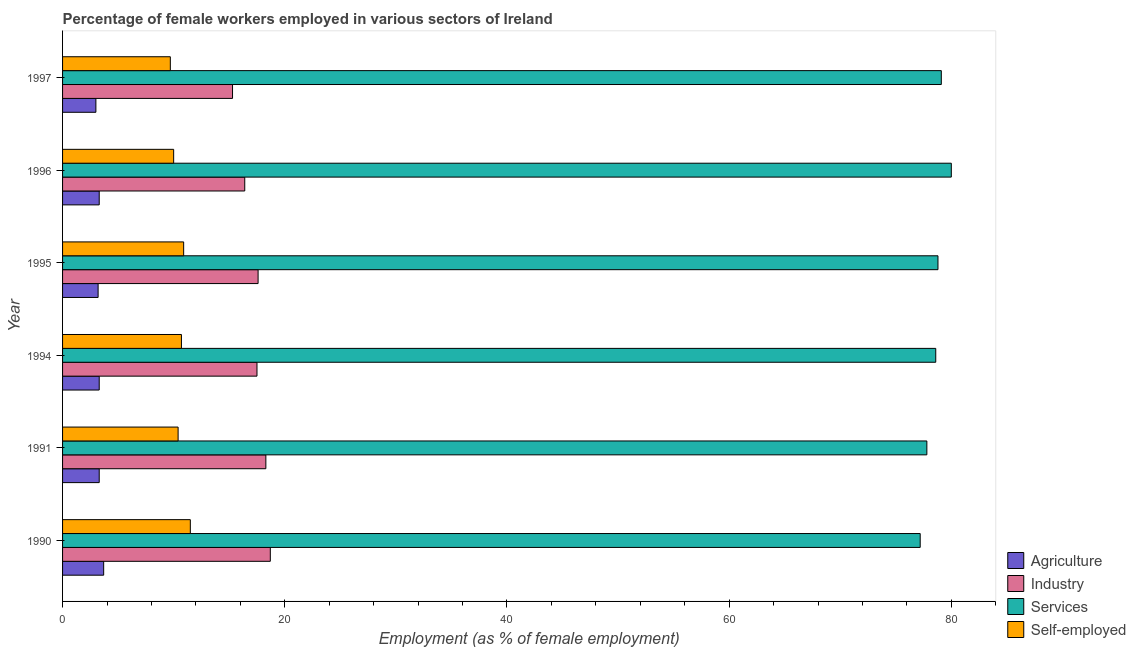Are the number of bars per tick equal to the number of legend labels?
Offer a terse response. Yes. Are the number of bars on each tick of the Y-axis equal?
Offer a very short reply. Yes. How many bars are there on the 5th tick from the top?
Offer a terse response. 4. How many bars are there on the 4th tick from the bottom?
Give a very brief answer. 4. What is the label of the 2nd group of bars from the top?
Your response must be concise. 1996. What is the percentage of female workers in services in 1995?
Give a very brief answer. 78.8. Across all years, what is the maximum percentage of female workers in industry?
Offer a very short reply. 18.7. In which year was the percentage of female workers in services maximum?
Give a very brief answer. 1996. In which year was the percentage of female workers in services minimum?
Offer a very short reply. 1990. What is the total percentage of female workers in industry in the graph?
Provide a short and direct response. 103.8. What is the difference between the percentage of self employed female workers in 1990 and that in 1991?
Your response must be concise. 1.1. What is the difference between the percentage of female workers in services in 1996 and the percentage of self employed female workers in 1994?
Offer a terse response. 69.3. What is the average percentage of self employed female workers per year?
Offer a very short reply. 10.53. In the year 1991, what is the difference between the percentage of self employed female workers and percentage of female workers in industry?
Make the answer very short. -7.9. In how many years, is the percentage of female workers in industry greater than 32 %?
Ensure brevity in your answer.  0. What is the ratio of the percentage of female workers in industry in 1991 to that in 1994?
Your response must be concise. 1.05. Is the percentage of female workers in agriculture in 1990 less than that in 1997?
Your answer should be compact. No. Is the difference between the percentage of female workers in industry in 1994 and 1997 greater than the difference between the percentage of self employed female workers in 1994 and 1997?
Provide a succinct answer. Yes. What is the difference between the highest and the second highest percentage of female workers in agriculture?
Offer a terse response. 0.4. In how many years, is the percentage of female workers in services greater than the average percentage of female workers in services taken over all years?
Give a very brief answer. 4. Is the sum of the percentage of self employed female workers in 1996 and 1997 greater than the maximum percentage of female workers in industry across all years?
Offer a very short reply. Yes. What does the 1st bar from the top in 1997 represents?
Give a very brief answer. Self-employed. What does the 4th bar from the bottom in 1994 represents?
Offer a terse response. Self-employed. Is it the case that in every year, the sum of the percentage of female workers in agriculture and percentage of female workers in industry is greater than the percentage of female workers in services?
Ensure brevity in your answer.  No. How many bars are there?
Ensure brevity in your answer.  24. Does the graph contain any zero values?
Provide a succinct answer. No. Does the graph contain grids?
Keep it short and to the point. No. Where does the legend appear in the graph?
Make the answer very short. Bottom right. What is the title of the graph?
Ensure brevity in your answer.  Percentage of female workers employed in various sectors of Ireland. What is the label or title of the X-axis?
Offer a very short reply. Employment (as % of female employment). What is the label or title of the Y-axis?
Your answer should be compact. Year. What is the Employment (as % of female employment) in Agriculture in 1990?
Give a very brief answer. 3.7. What is the Employment (as % of female employment) of Industry in 1990?
Provide a succinct answer. 18.7. What is the Employment (as % of female employment) of Services in 1990?
Provide a short and direct response. 77.2. What is the Employment (as % of female employment) in Self-employed in 1990?
Make the answer very short. 11.5. What is the Employment (as % of female employment) in Agriculture in 1991?
Offer a terse response. 3.3. What is the Employment (as % of female employment) of Industry in 1991?
Provide a succinct answer. 18.3. What is the Employment (as % of female employment) of Services in 1991?
Your answer should be very brief. 77.8. What is the Employment (as % of female employment) in Self-employed in 1991?
Your answer should be very brief. 10.4. What is the Employment (as % of female employment) in Agriculture in 1994?
Your response must be concise. 3.3. What is the Employment (as % of female employment) in Services in 1994?
Make the answer very short. 78.6. What is the Employment (as % of female employment) in Self-employed in 1994?
Give a very brief answer. 10.7. What is the Employment (as % of female employment) of Agriculture in 1995?
Provide a succinct answer. 3.2. What is the Employment (as % of female employment) in Industry in 1995?
Provide a succinct answer. 17.6. What is the Employment (as % of female employment) in Services in 1995?
Give a very brief answer. 78.8. What is the Employment (as % of female employment) in Self-employed in 1995?
Your response must be concise. 10.9. What is the Employment (as % of female employment) of Agriculture in 1996?
Make the answer very short. 3.3. What is the Employment (as % of female employment) of Industry in 1996?
Provide a short and direct response. 16.4. What is the Employment (as % of female employment) of Self-employed in 1996?
Provide a succinct answer. 10. What is the Employment (as % of female employment) of Agriculture in 1997?
Your answer should be compact. 3. What is the Employment (as % of female employment) in Industry in 1997?
Offer a very short reply. 15.3. What is the Employment (as % of female employment) of Services in 1997?
Provide a succinct answer. 79.1. What is the Employment (as % of female employment) of Self-employed in 1997?
Make the answer very short. 9.7. Across all years, what is the maximum Employment (as % of female employment) of Agriculture?
Ensure brevity in your answer.  3.7. Across all years, what is the maximum Employment (as % of female employment) in Industry?
Offer a terse response. 18.7. Across all years, what is the minimum Employment (as % of female employment) in Agriculture?
Make the answer very short. 3. Across all years, what is the minimum Employment (as % of female employment) in Industry?
Ensure brevity in your answer.  15.3. Across all years, what is the minimum Employment (as % of female employment) in Services?
Give a very brief answer. 77.2. Across all years, what is the minimum Employment (as % of female employment) in Self-employed?
Keep it short and to the point. 9.7. What is the total Employment (as % of female employment) of Agriculture in the graph?
Your answer should be compact. 19.8. What is the total Employment (as % of female employment) of Industry in the graph?
Offer a terse response. 103.8. What is the total Employment (as % of female employment) of Services in the graph?
Ensure brevity in your answer.  471.5. What is the total Employment (as % of female employment) in Self-employed in the graph?
Provide a succinct answer. 63.2. What is the difference between the Employment (as % of female employment) in Agriculture in 1990 and that in 1991?
Your answer should be compact. 0.4. What is the difference between the Employment (as % of female employment) in Industry in 1990 and that in 1991?
Ensure brevity in your answer.  0.4. What is the difference between the Employment (as % of female employment) of Services in 1990 and that in 1991?
Your answer should be compact. -0.6. What is the difference between the Employment (as % of female employment) in Agriculture in 1990 and that in 1994?
Provide a short and direct response. 0.4. What is the difference between the Employment (as % of female employment) in Agriculture in 1990 and that in 1995?
Provide a succinct answer. 0.5. What is the difference between the Employment (as % of female employment) in Industry in 1990 and that in 1995?
Provide a succinct answer. 1.1. What is the difference between the Employment (as % of female employment) in Services in 1990 and that in 1995?
Offer a very short reply. -1.6. What is the difference between the Employment (as % of female employment) of Self-employed in 1990 and that in 1995?
Your response must be concise. 0.6. What is the difference between the Employment (as % of female employment) in Industry in 1990 and that in 1996?
Your response must be concise. 2.3. What is the difference between the Employment (as % of female employment) of Self-employed in 1990 and that in 1996?
Offer a very short reply. 1.5. What is the difference between the Employment (as % of female employment) in Agriculture in 1990 and that in 1997?
Keep it short and to the point. 0.7. What is the difference between the Employment (as % of female employment) in Industry in 1990 and that in 1997?
Your answer should be compact. 3.4. What is the difference between the Employment (as % of female employment) in Services in 1990 and that in 1997?
Your answer should be very brief. -1.9. What is the difference between the Employment (as % of female employment) of Self-employed in 1990 and that in 1997?
Offer a terse response. 1.8. What is the difference between the Employment (as % of female employment) in Agriculture in 1991 and that in 1994?
Your answer should be very brief. 0. What is the difference between the Employment (as % of female employment) in Services in 1991 and that in 1994?
Provide a short and direct response. -0.8. What is the difference between the Employment (as % of female employment) in Industry in 1991 and that in 1995?
Give a very brief answer. 0.7. What is the difference between the Employment (as % of female employment) of Agriculture in 1991 and that in 1996?
Provide a succinct answer. 0. What is the difference between the Employment (as % of female employment) of Self-employed in 1991 and that in 1996?
Offer a very short reply. 0.4. What is the difference between the Employment (as % of female employment) of Agriculture in 1991 and that in 1997?
Provide a succinct answer. 0.3. What is the difference between the Employment (as % of female employment) of Industry in 1991 and that in 1997?
Your answer should be compact. 3. What is the difference between the Employment (as % of female employment) in Agriculture in 1994 and that in 1995?
Offer a very short reply. 0.1. What is the difference between the Employment (as % of female employment) in Services in 1994 and that in 1995?
Offer a terse response. -0.2. What is the difference between the Employment (as % of female employment) in Services in 1994 and that in 1996?
Your response must be concise. -1.4. What is the difference between the Employment (as % of female employment) in Agriculture in 1994 and that in 1997?
Your response must be concise. 0.3. What is the difference between the Employment (as % of female employment) of Industry in 1994 and that in 1997?
Your response must be concise. 2.2. What is the difference between the Employment (as % of female employment) of Self-employed in 1994 and that in 1997?
Make the answer very short. 1. What is the difference between the Employment (as % of female employment) in Self-employed in 1995 and that in 1996?
Make the answer very short. 0.9. What is the difference between the Employment (as % of female employment) in Agriculture in 1995 and that in 1997?
Your answer should be compact. 0.2. What is the difference between the Employment (as % of female employment) in Services in 1995 and that in 1997?
Your response must be concise. -0.3. What is the difference between the Employment (as % of female employment) of Self-employed in 1995 and that in 1997?
Offer a terse response. 1.2. What is the difference between the Employment (as % of female employment) in Self-employed in 1996 and that in 1997?
Provide a short and direct response. 0.3. What is the difference between the Employment (as % of female employment) in Agriculture in 1990 and the Employment (as % of female employment) in Industry in 1991?
Offer a terse response. -14.6. What is the difference between the Employment (as % of female employment) of Agriculture in 1990 and the Employment (as % of female employment) of Services in 1991?
Make the answer very short. -74.1. What is the difference between the Employment (as % of female employment) of Industry in 1990 and the Employment (as % of female employment) of Services in 1991?
Provide a short and direct response. -59.1. What is the difference between the Employment (as % of female employment) of Industry in 1990 and the Employment (as % of female employment) of Self-employed in 1991?
Ensure brevity in your answer.  8.3. What is the difference between the Employment (as % of female employment) in Services in 1990 and the Employment (as % of female employment) in Self-employed in 1991?
Your response must be concise. 66.8. What is the difference between the Employment (as % of female employment) of Agriculture in 1990 and the Employment (as % of female employment) of Industry in 1994?
Offer a terse response. -13.8. What is the difference between the Employment (as % of female employment) of Agriculture in 1990 and the Employment (as % of female employment) of Services in 1994?
Make the answer very short. -74.9. What is the difference between the Employment (as % of female employment) in Agriculture in 1990 and the Employment (as % of female employment) in Self-employed in 1994?
Provide a succinct answer. -7. What is the difference between the Employment (as % of female employment) in Industry in 1990 and the Employment (as % of female employment) in Services in 1994?
Your response must be concise. -59.9. What is the difference between the Employment (as % of female employment) of Services in 1990 and the Employment (as % of female employment) of Self-employed in 1994?
Offer a very short reply. 66.5. What is the difference between the Employment (as % of female employment) in Agriculture in 1990 and the Employment (as % of female employment) in Industry in 1995?
Your answer should be compact. -13.9. What is the difference between the Employment (as % of female employment) in Agriculture in 1990 and the Employment (as % of female employment) in Services in 1995?
Provide a short and direct response. -75.1. What is the difference between the Employment (as % of female employment) of Agriculture in 1990 and the Employment (as % of female employment) of Self-employed in 1995?
Your answer should be compact. -7.2. What is the difference between the Employment (as % of female employment) of Industry in 1990 and the Employment (as % of female employment) of Services in 1995?
Provide a short and direct response. -60.1. What is the difference between the Employment (as % of female employment) in Services in 1990 and the Employment (as % of female employment) in Self-employed in 1995?
Give a very brief answer. 66.3. What is the difference between the Employment (as % of female employment) of Agriculture in 1990 and the Employment (as % of female employment) of Industry in 1996?
Offer a terse response. -12.7. What is the difference between the Employment (as % of female employment) of Agriculture in 1990 and the Employment (as % of female employment) of Services in 1996?
Give a very brief answer. -76.3. What is the difference between the Employment (as % of female employment) of Agriculture in 1990 and the Employment (as % of female employment) of Self-employed in 1996?
Ensure brevity in your answer.  -6.3. What is the difference between the Employment (as % of female employment) in Industry in 1990 and the Employment (as % of female employment) in Services in 1996?
Offer a terse response. -61.3. What is the difference between the Employment (as % of female employment) in Services in 1990 and the Employment (as % of female employment) in Self-employed in 1996?
Your answer should be very brief. 67.2. What is the difference between the Employment (as % of female employment) of Agriculture in 1990 and the Employment (as % of female employment) of Industry in 1997?
Provide a short and direct response. -11.6. What is the difference between the Employment (as % of female employment) of Agriculture in 1990 and the Employment (as % of female employment) of Services in 1997?
Provide a succinct answer. -75.4. What is the difference between the Employment (as % of female employment) of Industry in 1990 and the Employment (as % of female employment) of Services in 1997?
Make the answer very short. -60.4. What is the difference between the Employment (as % of female employment) in Services in 1990 and the Employment (as % of female employment) in Self-employed in 1997?
Ensure brevity in your answer.  67.5. What is the difference between the Employment (as % of female employment) of Agriculture in 1991 and the Employment (as % of female employment) of Industry in 1994?
Give a very brief answer. -14.2. What is the difference between the Employment (as % of female employment) of Agriculture in 1991 and the Employment (as % of female employment) of Services in 1994?
Provide a short and direct response. -75.3. What is the difference between the Employment (as % of female employment) in Industry in 1991 and the Employment (as % of female employment) in Services in 1994?
Provide a succinct answer. -60.3. What is the difference between the Employment (as % of female employment) in Services in 1991 and the Employment (as % of female employment) in Self-employed in 1994?
Keep it short and to the point. 67.1. What is the difference between the Employment (as % of female employment) in Agriculture in 1991 and the Employment (as % of female employment) in Industry in 1995?
Provide a succinct answer. -14.3. What is the difference between the Employment (as % of female employment) in Agriculture in 1991 and the Employment (as % of female employment) in Services in 1995?
Ensure brevity in your answer.  -75.5. What is the difference between the Employment (as % of female employment) in Industry in 1991 and the Employment (as % of female employment) in Services in 1995?
Give a very brief answer. -60.5. What is the difference between the Employment (as % of female employment) in Industry in 1991 and the Employment (as % of female employment) in Self-employed in 1995?
Ensure brevity in your answer.  7.4. What is the difference between the Employment (as % of female employment) in Services in 1991 and the Employment (as % of female employment) in Self-employed in 1995?
Provide a succinct answer. 66.9. What is the difference between the Employment (as % of female employment) in Agriculture in 1991 and the Employment (as % of female employment) in Services in 1996?
Keep it short and to the point. -76.7. What is the difference between the Employment (as % of female employment) in Agriculture in 1991 and the Employment (as % of female employment) in Self-employed in 1996?
Your answer should be compact. -6.7. What is the difference between the Employment (as % of female employment) in Industry in 1991 and the Employment (as % of female employment) in Services in 1996?
Keep it short and to the point. -61.7. What is the difference between the Employment (as % of female employment) of Industry in 1991 and the Employment (as % of female employment) of Self-employed in 1996?
Give a very brief answer. 8.3. What is the difference between the Employment (as % of female employment) in Services in 1991 and the Employment (as % of female employment) in Self-employed in 1996?
Your response must be concise. 67.8. What is the difference between the Employment (as % of female employment) of Agriculture in 1991 and the Employment (as % of female employment) of Services in 1997?
Ensure brevity in your answer.  -75.8. What is the difference between the Employment (as % of female employment) in Agriculture in 1991 and the Employment (as % of female employment) in Self-employed in 1997?
Offer a very short reply. -6.4. What is the difference between the Employment (as % of female employment) of Industry in 1991 and the Employment (as % of female employment) of Services in 1997?
Offer a very short reply. -60.8. What is the difference between the Employment (as % of female employment) of Services in 1991 and the Employment (as % of female employment) of Self-employed in 1997?
Your answer should be compact. 68.1. What is the difference between the Employment (as % of female employment) in Agriculture in 1994 and the Employment (as % of female employment) in Industry in 1995?
Ensure brevity in your answer.  -14.3. What is the difference between the Employment (as % of female employment) of Agriculture in 1994 and the Employment (as % of female employment) of Services in 1995?
Offer a terse response. -75.5. What is the difference between the Employment (as % of female employment) of Industry in 1994 and the Employment (as % of female employment) of Services in 1995?
Offer a very short reply. -61.3. What is the difference between the Employment (as % of female employment) in Industry in 1994 and the Employment (as % of female employment) in Self-employed in 1995?
Make the answer very short. 6.6. What is the difference between the Employment (as % of female employment) in Services in 1994 and the Employment (as % of female employment) in Self-employed in 1995?
Ensure brevity in your answer.  67.7. What is the difference between the Employment (as % of female employment) in Agriculture in 1994 and the Employment (as % of female employment) in Services in 1996?
Offer a terse response. -76.7. What is the difference between the Employment (as % of female employment) of Agriculture in 1994 and the Employment (as % of female employment) of Self-employed in 1996?
Offer a terse response. -6.7. What is the difference between the Employment (as % of female employment) in Industry in 1994 and the Employment (as % of female employment) in Services in 1996?
Offer a terse response. -62.5. What is the difference between the Employment (as % of female employment) of Services in 1994 and the Employment (as % of female employment) of Self-employed in 1996?
Provide a succinct answer. 68.6. What is the difference between the Employment (as % of female employment) in Agriculture in 1994 and the Employment (as % of female employment) in Industry in 1997?
Ensure brevity in your answer.  -12. What is the difference between the Employment (as % of female employment) of Agriculture in 1994 and the Employment (as % of female employment) of Services in 1997?
Keep it short and to the point. -75.8. What is the difference between the Employment (as % of female employment) in Industry in 1994 and the Employment (as % of female employment) in Services in 1997?
Provide a short and direct response. -61.6. What is the difference between the Employment (as % of female employment) of Industry in 1994 and the Employment (as % of female employment) of Self-employed in 1997?
Offer a very short reply. 7.8. What is the difference between the Employment (as % of female employment) of Services in 1994 and the Employment (as % of female employment) of Self-employed in 1997?
Give a very brief answer. 68.9. What is the difference between the Employment (as % of female employment) in Agriculture in 1995 and the Employment (as % of female employment) in Industry in 1996?
Provide a short and direct response. -13.2. What is the difference between the Employment (as % of female employment) of Agriculture in 1995 and the Employment (as % of female employment) of Services in 1996?
Provide a succinct answer. -76.8. What is the difference between the Employment (as % of female employment) in Agriculture in 1995 and the Employment (as % of female employment) in Self-employed in 1996?
Make the answer very short. -6.8. What is the difference between the Employment (as % of female employment) in Industry in 1995 and the Employment (as % of female employment) in Services in 1996?
Provide a short and direct response. -62.4. What is the difference between the Employment (as % of female employment) in Services in 1995 and the Employment (as % of female employment) in Self-employed in 1996?
Your answer should be compact. 68.8. What is the difference between the Employment (as % of female employment) of Agriculture in 1995 and the Employment (as % of female employment) of Services in 1997?
Give a very brief answer. -75.9. What is the difference between the Employment (as % of female employment) of Agriculture in 1995 and the Employment (as % of female employment) of Self-employed in 1997?
Provide a short and direct response. -6.5. What is the difference between the Employment (as % of female employment) of Industry in 1995 and the Employment (as % of female employment) of Services in 1997?
Keep it short and to the point. -61.5. What is the difference between the Employment (as % of female employment) in Industry in 1995 and the Employment (as % of female employment) in Self-employed in 1997?
Your answer should be compact. 7.9. What is the difference between the Employment (as % of female employment) in Services in 1995 and the Employment (as % of female employment) in Self-employed in 1997?
Make the answer very short. 69.1. What is the difference between the Employment (as % of female employment) of Agriculture in 1996 and the Employment (as % of female employment) of Services in 1997?
Offer a very short reply. -75.8. What is the difference between the Employment (as % of female employment) in Agriculture in 1996 and the Employment (as % of female employment) in Self-employed in 1997?
Ensure brevity in your answer.  -6.4. What is the difference between the Employment (as % of female employment) of Industry in 1996 and the Employment (as % of female employment) of Services in 1997?
Offer a terse response. -62.7. What is the difference between the Employment (as % of female employment) in Industry in 1996 and the Employment (as % of female employment) in Self-employed in 1997?
Give a very brief answer. 6.7. What is the difference between the Employment (as % of female employment) in Services in 1996 and the Employment (as % of female employment) in Self-employed in 1997?
Ensure brevity in your answer.  70.3. What is the average Employment (as % of female employment) in Services per year?
Make the answer very short. 78.58. What is the average Employment (as % of female employment) of Self-employed per year?
Your answer should be compact. 10.53. In the year 1990, what is the difference between the Employment (as % of female employment) of Agriculture and Employment (as % of female employment) of Services?
Your answer should be compact. -73.5. In the year 1990, what is the difference between the Employment (as % of female employment) in Industry and Employment (as % of female employment) in Services?
Make the answer very short. -58.5. In the year 1990, what is the difference between the Employment (as % of female employment) of Industry and Employment (as % of female employment) of Self-employed?
Keep it short and to the point. 7.2. In the year 1990, what is the difference between the Employment (as % of female employment) of Services and Employment (as % of female employment) of Self-employed?
Offer a terse response. 65.7. In the year 1991, what is the difference between the Employment (as % of female employment) in Agriculture and Employment (as % of female employment) in Services?
Your answer should be very brief. -74.5. In the year 1991, what is the difference between the Employment (as % of female employment) of Agriculture and Employment (as % of female employment) of Self-employed?
Make the answer very short. -7.1. In the year 1991, what is the difference between the Employment (as % of female employment) in Industry and Employment (as % of female employment) in Services?
Give a very brief answer. -59.5. In the year 1991, what is the difference between the Employment (as % of female employment) of Industry and Employment (as % of female employment) of Self-employed?
Your answer should be compact. 7.9. In the year 1991, what is the difference between the Employment (as % of female employment) in Services and Employment (as % of female employment) in Self-employed?
Make the answer very short. 67.4. In the year 1994, what is the difference between the Employment (as % of female employment) of Agriculture and Employment (as % of female employment) of Industry?
Your answer should be very brief. -14.2. In the year 1994, what is the difference between the Employment (as % of female employment) of Agriculture and Employment (as % of female employment) of Services?
Your answer should be very brief. -75.3. In the year 1994, what is the difference between the Employment (as % of female employment) in Agriculture and Employment (as % of female employment) in Self-employed?
Provide a succinct answer. -7.4. In the year 1994, what is the difference between the Employment (as % of female employment) of Industry and Employment (as % of female employment) of Services?
Provide a short and direct response. -61.1. In the year 1994, what is the difference between the Employment (as % of female employment) in Industry and Employment (as % of female employment) in Self-employed?
Keep it short and to the point. 6.8. In the year 1994, what is the difference between the Employment (as % of female employment) of Services and Employment (as % of female employment) of Self-employed?
Your answer should be compact. 67.9. In the year 1995, what is the difference between the Employment (as % of female employment) of Agriculture and Employment (as % of female employment) of Industry?
Make the answer very short. -14.4. In the year 1995, what is the difference between the Employment (as % of female employment) in Agriculture and Employment (as % of female employment) in Services?
Your answer should be very brief. -75.6. In the year 1995, what is the difference between the Employment (as % of female employment) in Industry and Employment (as % of female employment) in Services?
Give a very brief answer. -61.2. In the year 1995, what is the difference between the Employment (as % of female employment) in Industry and Employment (as % of female employment) in Self-employed?
Offer a very short reply. 6.7. In the year 1995, what is the difference between the Employment (as % of female employment) in Services and Employment (as % of female employment) in Self-employed?
Provide a short and direct response. 67.9. In the year 1996, what is the difference between the Employment (as % of female employment) in Agriculture and Employment (as % of female employment) in Industry?
Your answer should be compact. -13.1. In the year 1996, what is the difference between the Employment (as % of female employment) of Agriculture and Employment (as % of female employment) of Services?
Your answer should be compact. -76.7. In the year 1996, what is the difference between the Employment (as % of female employment) in Industry and Employment (as % of female employment) in Services?
Make the answer very short. -63.6. In the year 1997, what is the difference between the Employment (as % of female employment) in Agriculture and Employment (as % of female employment) in Services?
Offer a terse response. -76.1. In the year 1997, what is the difference between the Employment (as % of female employment) of Industry and Employment (as % of female employment) of Services?
Make the answer very short. -63.8. In the year 1997, what is the difference between the Employment (as % of female employment) of Industry and Employment (as % of female employment) of Self-employed?
Keep it short and to the point. 5.6. In the year 1997, what is the difference between the Employment (as % of female employment) of Services and Employment (as % of female employment) of Self-employed?
Give a very brief answer. 69.4. What is the ratio of the Employment (as % of female employment) in Agriculture in 1990 to that in 1991?
Provide a succinct answer. 1.12. What is the ratio of the Employment (as % of female employment) in Industry in 1990 to that in 1991?
Provide a succinct answer. 1.02. What is the ratio of the Employment (as % of female employment) in Services in 1990 to that in 1991?
Offer a terse response. 0.99. What is the ratio of the Employment (as % of female employment) of Self-employed in 1990 to that in 1991?
Your answer should be compact. 1.11. What is the ratio of the Employment (as % of female employment) of Agriculture in 1990 to that in 1994?
Provide a short and direct response. 1.12. What is the ratio of the Employment (as % of female employment) of Industry in 1990 to that in 1994?
Offer a very short reply. 1.07. What is the ratio of the Employment (as % of female employment) of Services in 1990 to that in 1994?
Ensure brevity in your answer.  0.98. What is the ratio of the Employment (as % of female employment) in Self-employed in 1990 to that in 1994?
Offer a very short reply. 1.07. What is the ratio of the Employment (as % of female employment) in Agriculture in 1990 to that in 1995?
Your response must be concise. 1.16. What is the ratio of the Employment (as % of female employment) in Industry in 1990 to that in 1995?
Provide a short and direct response. 1.06. What is the ratio of the Employment (as % of female employment) of Services in 1990 to that in 1995?
Ensure brevity in your answer.  0.98. What is the ratio of the Employment (as % of female employment) in Self-employed in 1990 to that in 1995?
Keep it short and to the point. 1.05. What is the ratio of the Employment (as % of female employment) of Agriculture in 1990 to that in 1996?
Keep it short and to the point. 1.12. What is the ratio of the Employment (as % of female employment) of Industry in 1990 to that in 1996?
Give a very brief answer. 1.14. What is the ratio of the Employment (as % of female employment) of Self-employed in 1990 to that in 1996?
Make the answer very short. 1.15. What is the ratio of the Employment (as % of female employment) of Agriculture in 1990 to that in 1997?
Offer a terse response. 1.23. What is the ratio of the Employment (as % of female employment) of Industry in 1990 to that in 1997?
Your answer should be very brief. 1.22. What is the ratio of the Employment (as % of female employment) in Self-employed in 1990 to that in 1997?
Ensure brevity in your answer.  1.19. What is the ratio of the Employment (as % of female employment) of Industry in 1991 to that in 1994?
Keep it short and to the point. 1.05. What is the ratio of the Employment (as % of female employment) of Services in 1991 to that in 1994?
Your answer should be compact. 0.99. What is the ratio of the Employment (as % of female employment) in Self-employed in 1991 to that in 1994?
Give a very brief answer. 0.97. What is the ratio of the Employment (as % of female employment) in Agriculture in 1991 to that in 1995?
Keep it short and to the point. 1.03. What is the ratio of the Employment (as % of female employment) of Industry in 1991 to that in 1995?
Ensure brevity in your answer.  1.04. What is the ratio of the Employment (as % of female employment) of Services in 1991 to that in 1995?
Offer a very short reply. 0.99. What is the ratio of the Employment (as % of female employment) in Self-employed in 1991 to that in 1995?
Your answer should be very brief. 0.95. What is the ratio of the Employment (as % of female employment) in Agriculture in 1991 to that in 1996?
Your answer should be compact. 1. What is the ratio of the Employment (as % of female employment) in Industry in 1991 to that in 1996?
Your answer should be very brief. 1.12. What is the ratio of the Employment (as % of female employment) in Services in 1991 to that in 1996?
Keep it short and to the point. 0.97. What is the ratio of the Employment (as % of female employment) of Self-employed in 1991 to that in 1996?
Give a very brief answer. 1.04. What is the ratio of the Employment (as % of female employment) of Agriculture in 1991 to that in 1997?
Make the answer very short. 1.1. What is the ratio of the Employment (as % of female employment) in Industry in 1991 to that in 1997?
Keep it short and to the point. 1.2. What is the ratio of the Employment (as % of female employment) of Services in 1991 to that in 1997?
Provide a succinct answer. 0.98. What is the ratio of the Employment (as % of female employment) of Self-employed in 1991 to that in 1997?
Your answer should be compact. 1.07. What is the ratio of the Employment (as % of female employment) in Agriculture in 1994 to that in 1995?
Provide a succinct answer. 1.03. What is the ratio of the Employment (as % of female employment) in Services in 1994 to that in 1995?
Offer a very short reply. 1. What is the ratio of the Employment (as % of female employment) in Self-employed in 1994 to that in 1995?
Ensure brevity in your answer.  0.98. What is the ratio of the Employment (as % of female employment) in Industry in 1994 to that in 1996?
Provide a succinct answer. 1.07. What is the ratio of the Employment (as % of female employment) in Services in 1994 to that in 1996?
Your answer should be very brief. 0.98. What is the ratio of the Employment (as % of female employment) in Self-employed in 1994 to that in 1996?
Provide a succinct answer. 1.07. What is the ratio of the Employment (as % of female employment) in Agriculture in 1994 to that in 1997?
Give a very brief answer. 1.1. What is the ratio of the Employment (as % of female employment) of Industry in 1994 to that in 1997?
Keep it short and to the point. 1.14. What is the ratio of the Employment (as % of female employment) of Services in 1994 to that in 1997?
Offer a terse response. 0.99. What is the ratio of the Employment (as % of female employment) of Self-employed in 1994 to that in 1997?
Make the answer very short. 1.1. What is the ratio of the Employment (as % of female employment) of Agriculture in 1995 to that in 1996?
Give a very brief answer. 0.97. What is the ratio of the Employment (as % of female employment) in Industry in 1995 to that in 1996?
Offer a terse response. 1.07. What is the ratio of the Employment (as % of female employment) of Self-employed in 1995 to that in 1996?
Provide a succinct answer. 1.09. What is the ratio of the Employment (as % of female employment) in Agriculture in 1995 to that in 1997?
Offer a terse response. 1.07. What is the ratio of the Employment (as % of female employment) in Industry in 1995 to that in 1997?
Offer a terse response. 1.15. What is the ratio of the Employment (as % of female employment) in Self-employed in 1995 to that in 1997?
Offer a terse response. 1.12. What is the ratio of the Employment (as % of female employment) in Industry in 1996 to that in 1997?
Your response must be concise. 1.07. What is the ratio of the Employment (as % of female employment) of Services in 1996 to that in 1997?
Give a very brief answer. 1.01. What is the ratio of the Employment (as % of female employment) of Self-employed in 1996 to that in 1997?
Provide a succinct answer. 1.03. What is the difference between the highest and the second highest Employment (as % of female employment) of Agriculture?
Keep it short and to the point. 0.4. What is the difference between the highest and the second highest Employment (as % of female employment) in Industry?
Offer a terse response. 0.4. What is the difference between the highest and the second highest Employment (as % of female employment) in Services?
Make the answer very short. 0.9. What is the difference between the highest and the lowest Employment (as % of female employment) of Industry?
Provide a short and direct response. 3.4. 